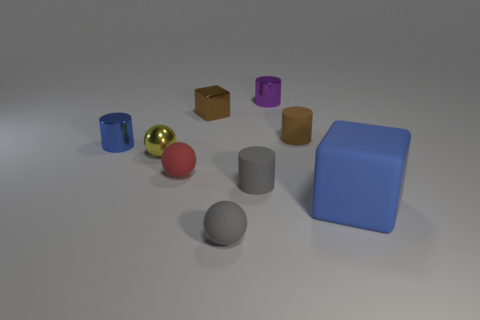How many big objects are either balls or green metal cylinders?
Your answer should be very brief. 0. Is there any other thing that has the same color as the small metal sphere?
Your answer should be compact. No. There is a gray matte cylinder; are there any small spheres on the right side of it?
Ensure brevity in your answer.  No. What is the size of the blue thing in front of the tiny metal cylinder in front of the small cube?
Offer a very short reply. Large. Are there an equal number of small red balls behind the tiny blue cylinder and brown blocks that are right of the purple shiny object?
Your answer should be very brief. Yes. There is a blue object to the right of the tiny shiny sphere; are there any matte cubes that are behind it?
Your response must be concise. No. What number of small shiny objects are in front of the matte thing behind the blue object behind the big blue rubber cube?
Keep it short and to the point. 2. Are there fewer brown metallic blocks than small yellow matte things?
Keep it short and to the point. No. Do the tiny red thing on the left side of the big blue block and the tiny rubber thing that is behind the tiny red sphere have the same shape?
Give a very brief answer. No. The big block is what color?
Offer a terse response. Blue. 